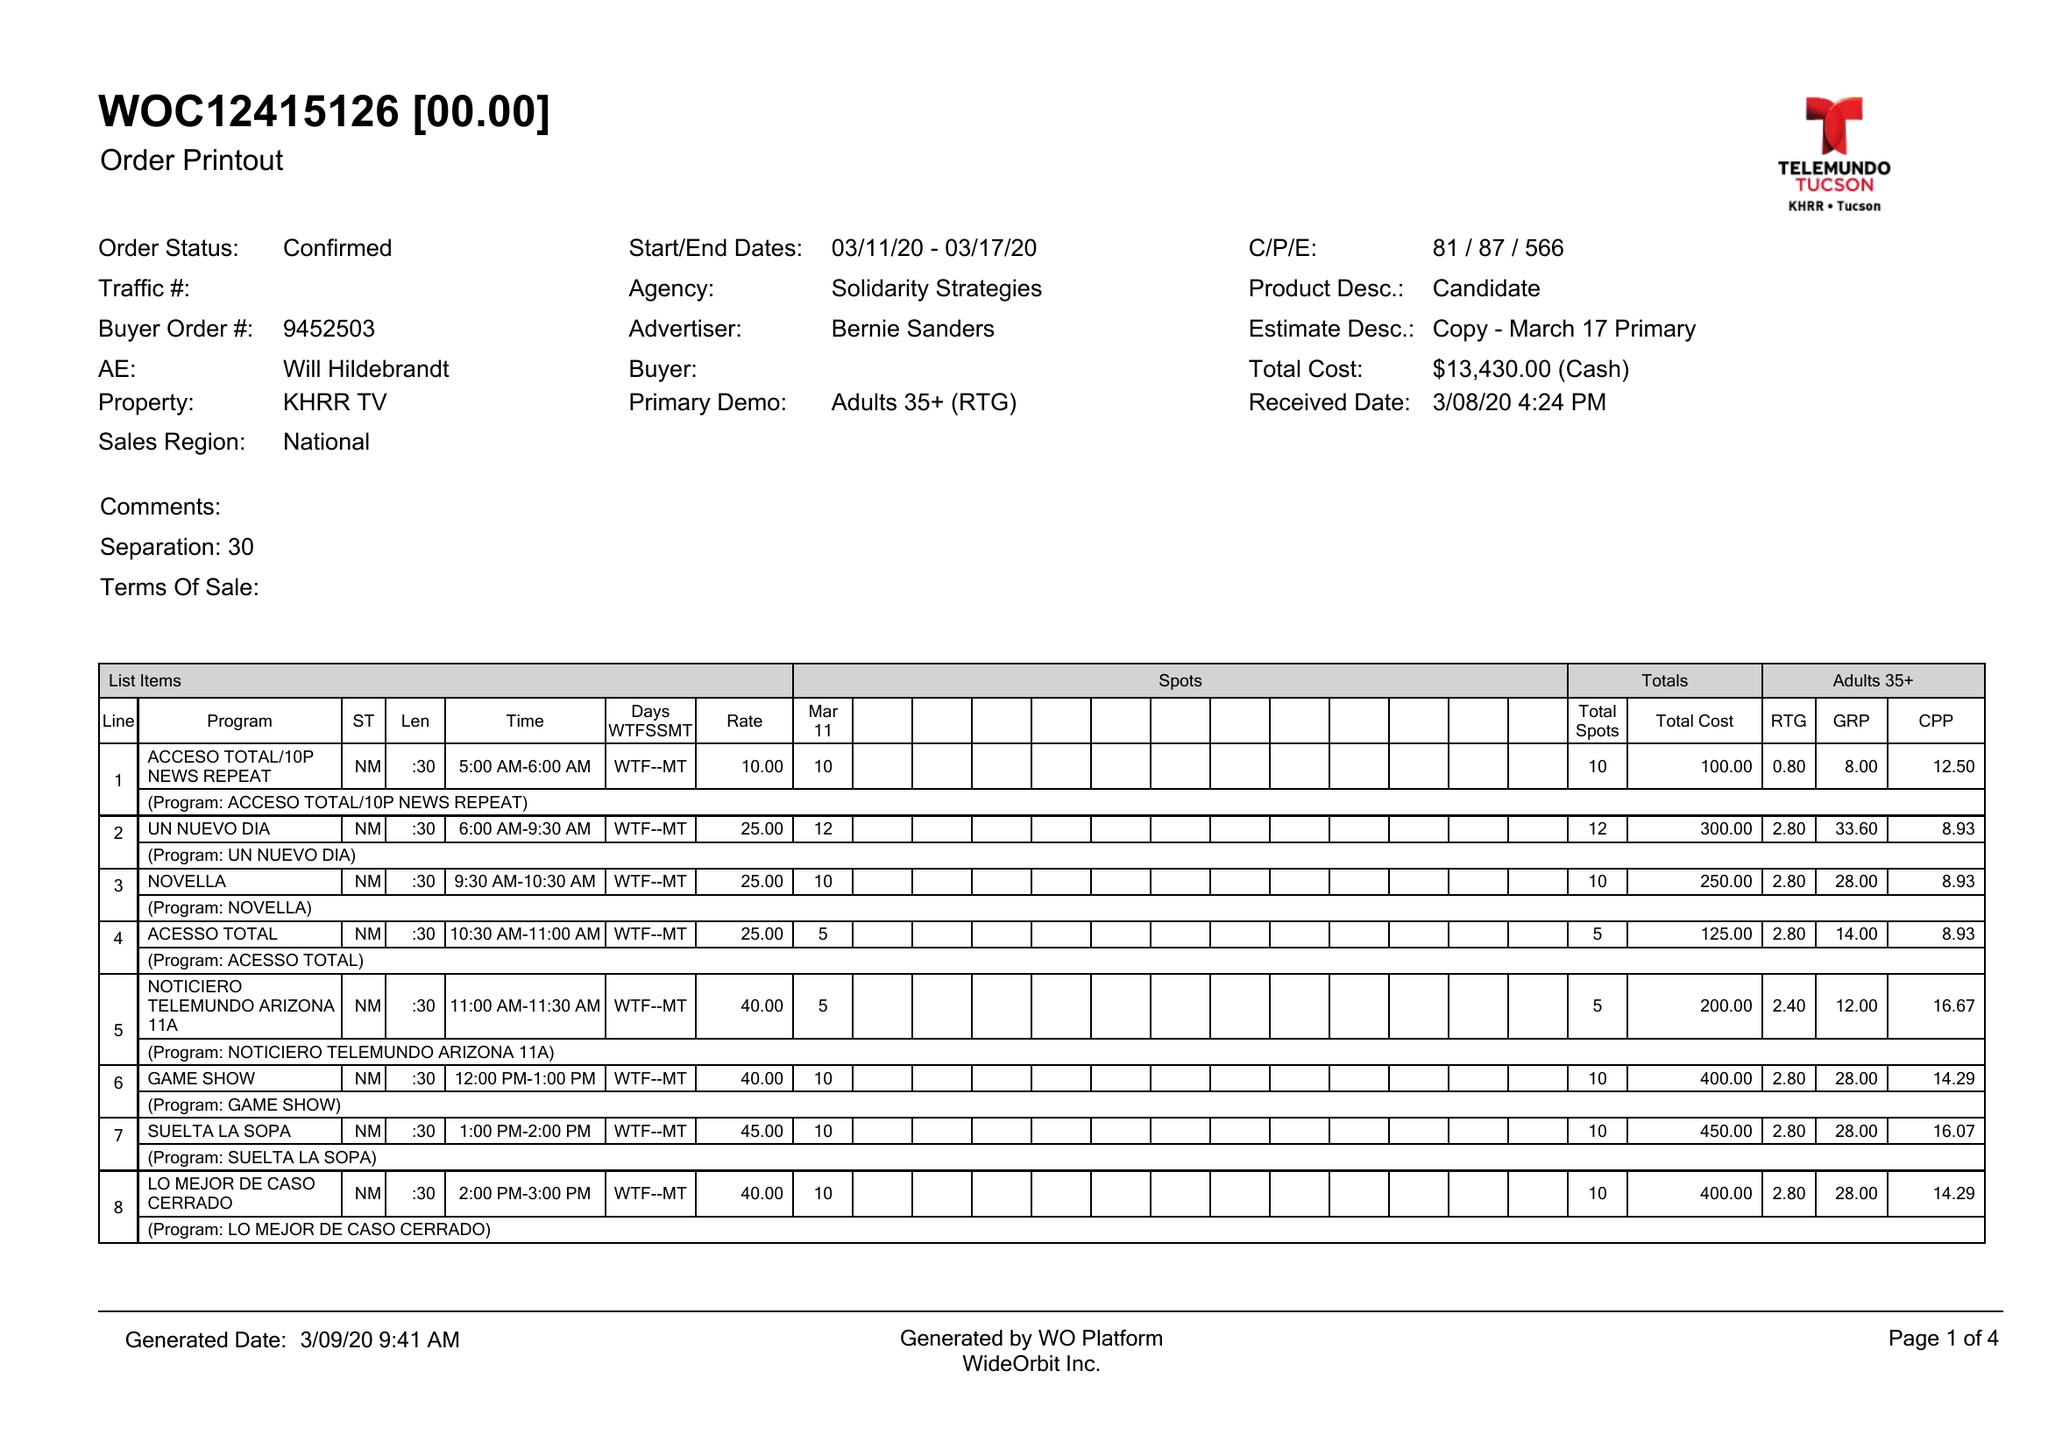What is the value for the contract_num?
Answer the question using a single word or phrase. 9452503 